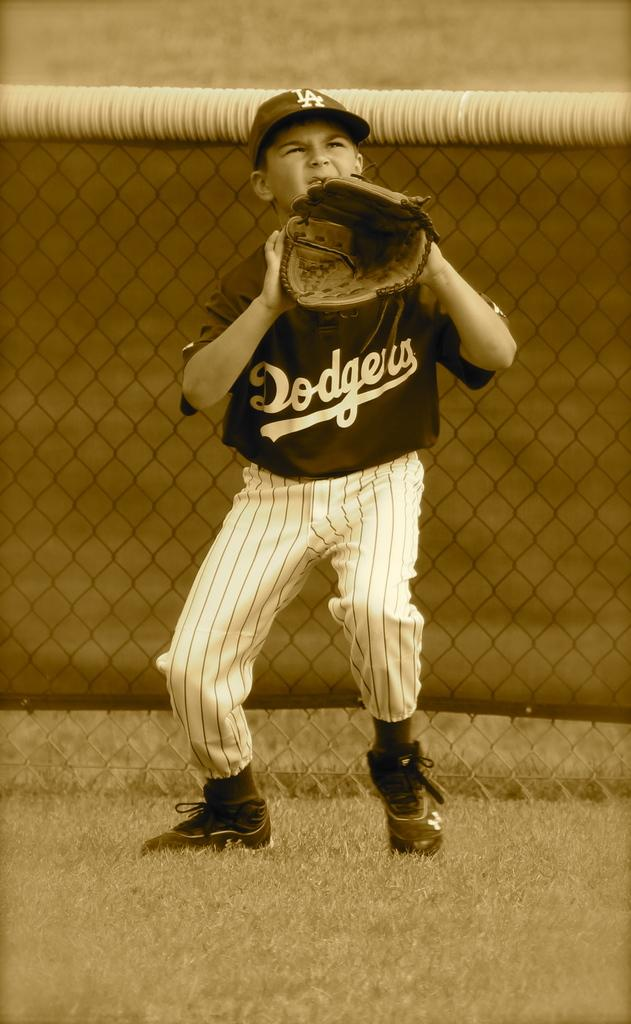<image>
Offer a succinct explanation of the picture presented. A boy playing for the Dodgers baseball is holding his glove and looking up in an attempt to catch the ball. 